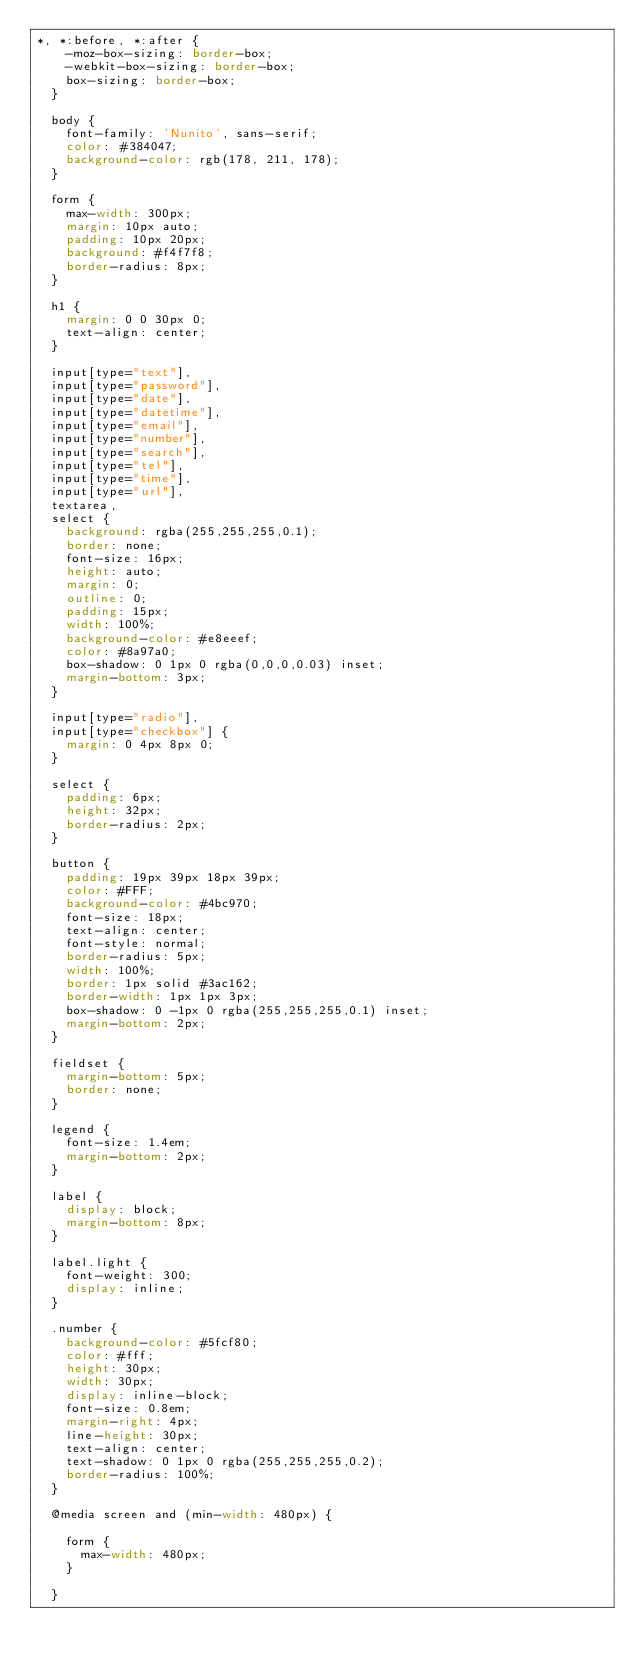Convert code to text. <code><loc_0><loc_0><loc_500><loc_500><_CSS_>*, *:before, *:after {
    -moz-box-sizing: border-box;
    -webkit-box-sizing: border-box;
    box-sizing: border-box;
  }
  
  body {
    font-family: 'Nunito', sans-serif;
    color: #384047;
    background-color: rgb(178, 211, 178);
  }
  
  form {
    max-width: 300px;
    margin: 10px auto;
    padding: 10px 20px;
    background: #f4f7f8;
    border-radius: 8px;
  }
  
  h1 {
    margin: 0 0 30px 0;
    text-align: center;
  }
  
  input[type="text"],
  input[type="password"],
  input[type="date"],
  input[type="datetime"],
  input[type="email"],
  input[type="number"],
  input[type="search"],
  input[type="tel"],
  input[type="time"],
  input[type="url"],
  textarea,
  select {
    background: rgba(255,255,255,0.1);
    border: none;
    font-size: 16px;
    height: auto;
    margin: 0;
    outline: 0;
    padding: 15px;
    width: 100%;
    background-color: #e8eeef;
    color: #8a97a0;
    box-shadow: 0 1px 0 rgba(0,0,0,0.03) inset;
    margin-bottom: 3px;
  }
  
  input[type="radio"],
  input[type="checkbox"] {
    margin: 0 4px 8px 0;
  }
  
  select {
    padding: 6px;
    height: 32px;
    border-radius: 2px;
  }
  
  button {
    padding: 19px 39px 18px 39px;
    color: #FFF;
    background-color: #4bc970;
    font-size: 18px;
    text-align: center;
    font-style: normal;
    border-radius: 5px;
    width: 100%;
    border: 1px solid #3ac162;
    border-width: 1px 1px 3px;
    box-shadow: 0 -1px 0 rgba(255,255,255,0.1) inset;
    margin-bottom: 2px;
  }
  
  fieldset {
    margin-bottom: 5px;
    border: none;
  }
  
  legend {
    font-size: 1.4em;
    margin-bottom: 2px;
  }
  
  label {
    display: block;
    margin-bottom: 8px;
  }
  
  label.light {
    font-weight: 300;
    display: inline;
  }
  
  .number {
    background-color: #5fcf80;
    color: #fff;
    height: 30px;
    width: 30px;
    display: inline-block;
    font-size: 0.8em;
    margin-right: 4px;
    line-height: 30px;
    text-align: center;
    text-shadow: 0 1px 0 rgba(255,255,255,0.2);
    border-radius: 100%;
  }
  
  @media screen and (min-width: 480px) {
  
    form {
      max-width: 480px;
    }
  
  }</code> 